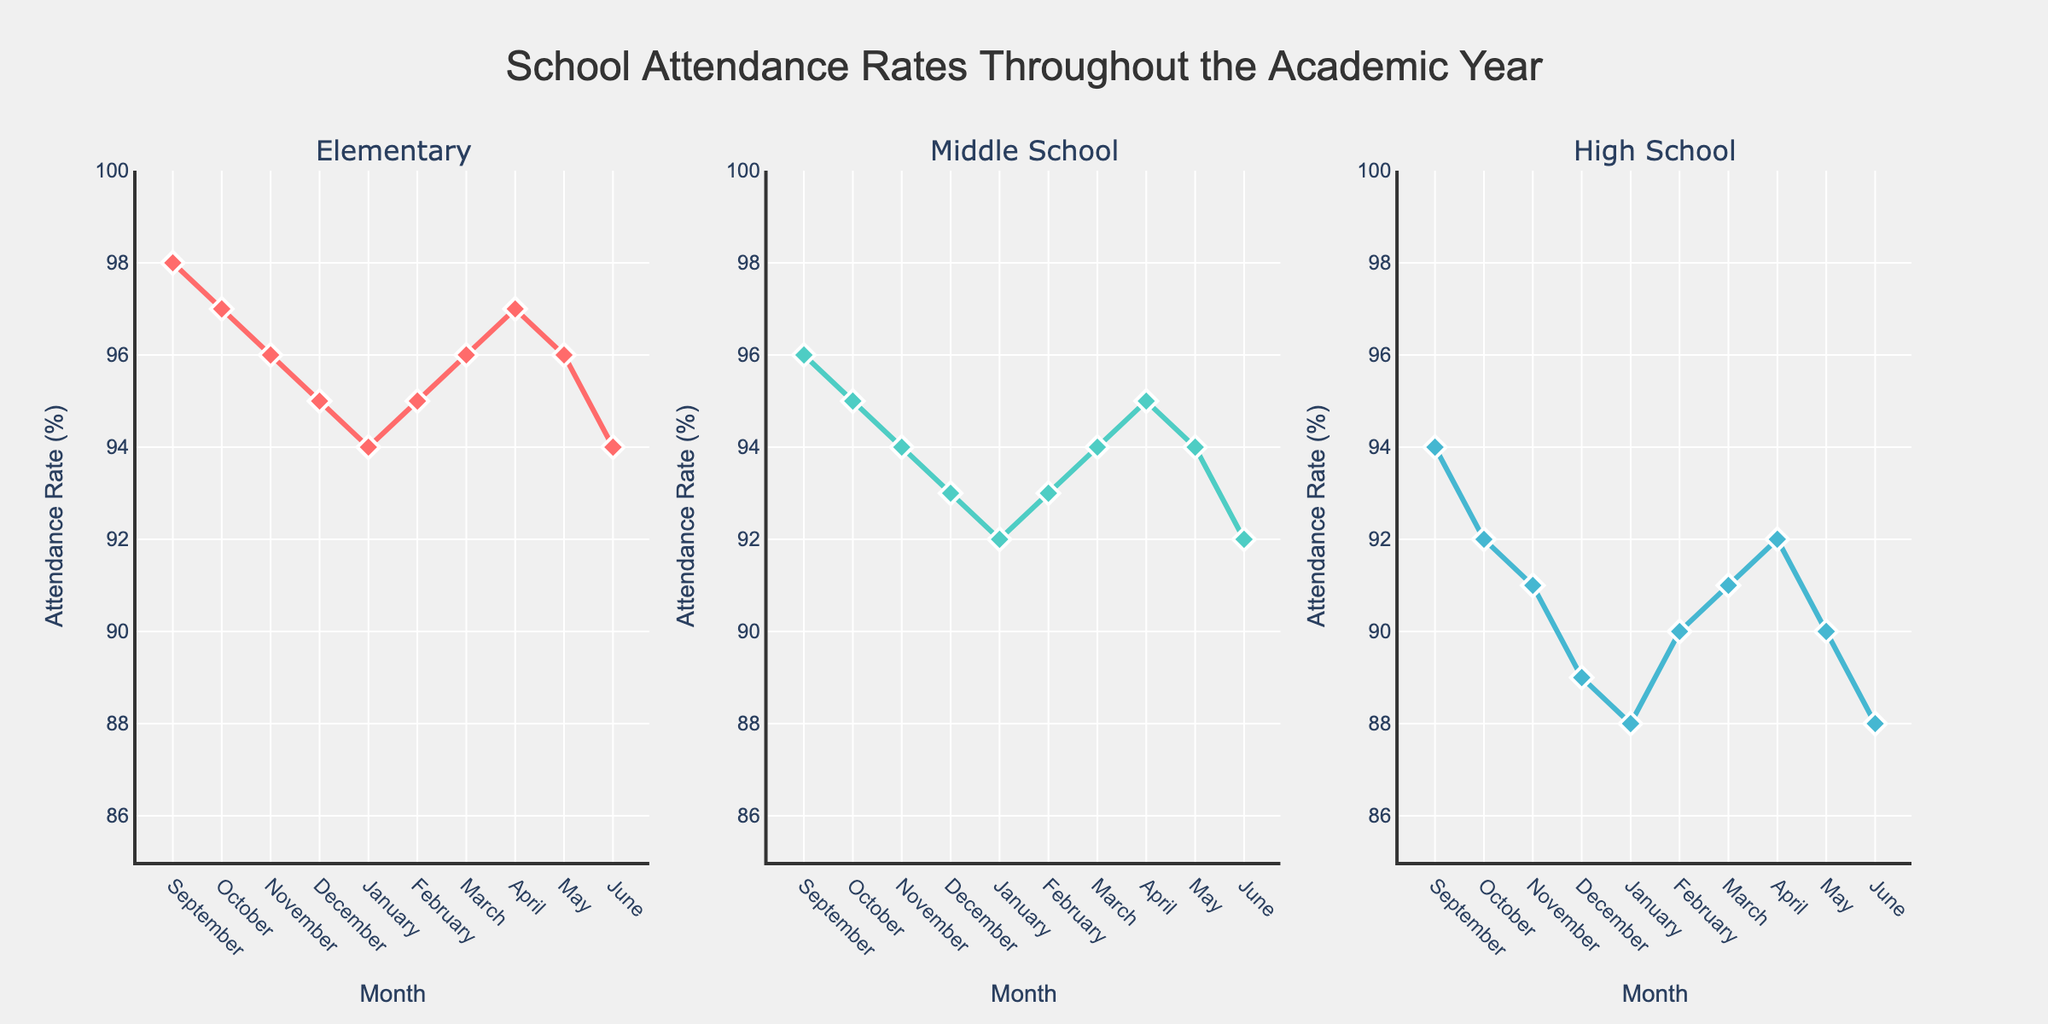How many grade levels are represented in the figure? The subplot titles indicate that there are three different grade levels represented in the figure: Elementary, Middle School, and High School.
Answer: Three What is the attendance rate for Elementary in February? Locate the Elementary subplot and follow the line to February. The attendance rate for Elementary in February is marked by a data point on the graph.
Answer: 95% Which month shows the highest attendance rate for High School? In the High School subplot, look for the highest data point along the y-axis and trace it back to the corresponding month on the x-axis. The highest attendance rate is in September.
Answer: September What is the difference in attendance rates between Elementary and High School in January? Find the attendance rates for Elementary (94%) and High School (88%) in January. Subtract the High School rate from the Elementary rate: 94 - 88.
Answer: 6% Which grade level has the most consistent attendance rate throughout the academic year? Compare the ups and downs of each subplot line. The Elementary grade level's line is relatively more stable with less variation compared to Middle School and High School.
Answer: Elementary What is the average attendance rate for Middle School across the months provided? Add all the attendance rates for Middle School (96 + 95 + 94 + 93 + 92 + 93 + 94 + 95 + 94 + 92) and divide by the number of months (10). The sum is 933, and the average is 933/10.
Answer: 93.3% In which month do all grade levels have their respective lowest attendance rates? Locate the lowest point in each subplot and note the corresponding month. All three grade levels have their lowest rates in June.
Answer: June How does the attendance trend for Elementary change from September to January? Look at the Elementary subplot and observe the direction of the line from September (98%) to January (94%). The trend is a gradual decline.
Answer: Gradual decline Compare the attendance rates of Middle School and High School in April. Which one is higher and by how much? Find the attendance rates for Middle School (95%) and High School (92%) in April. Subtract the High School rate from the Middle School rate: 95 - 92.
Answer: Middle School is higher by 3% What is the overall trend in attendance rates for High School across all months? Observe the High School subplot, noting the initial high point in September (94%) and the lowest in June (88%). The overall trend is a decrease.
Answer: Decrease 